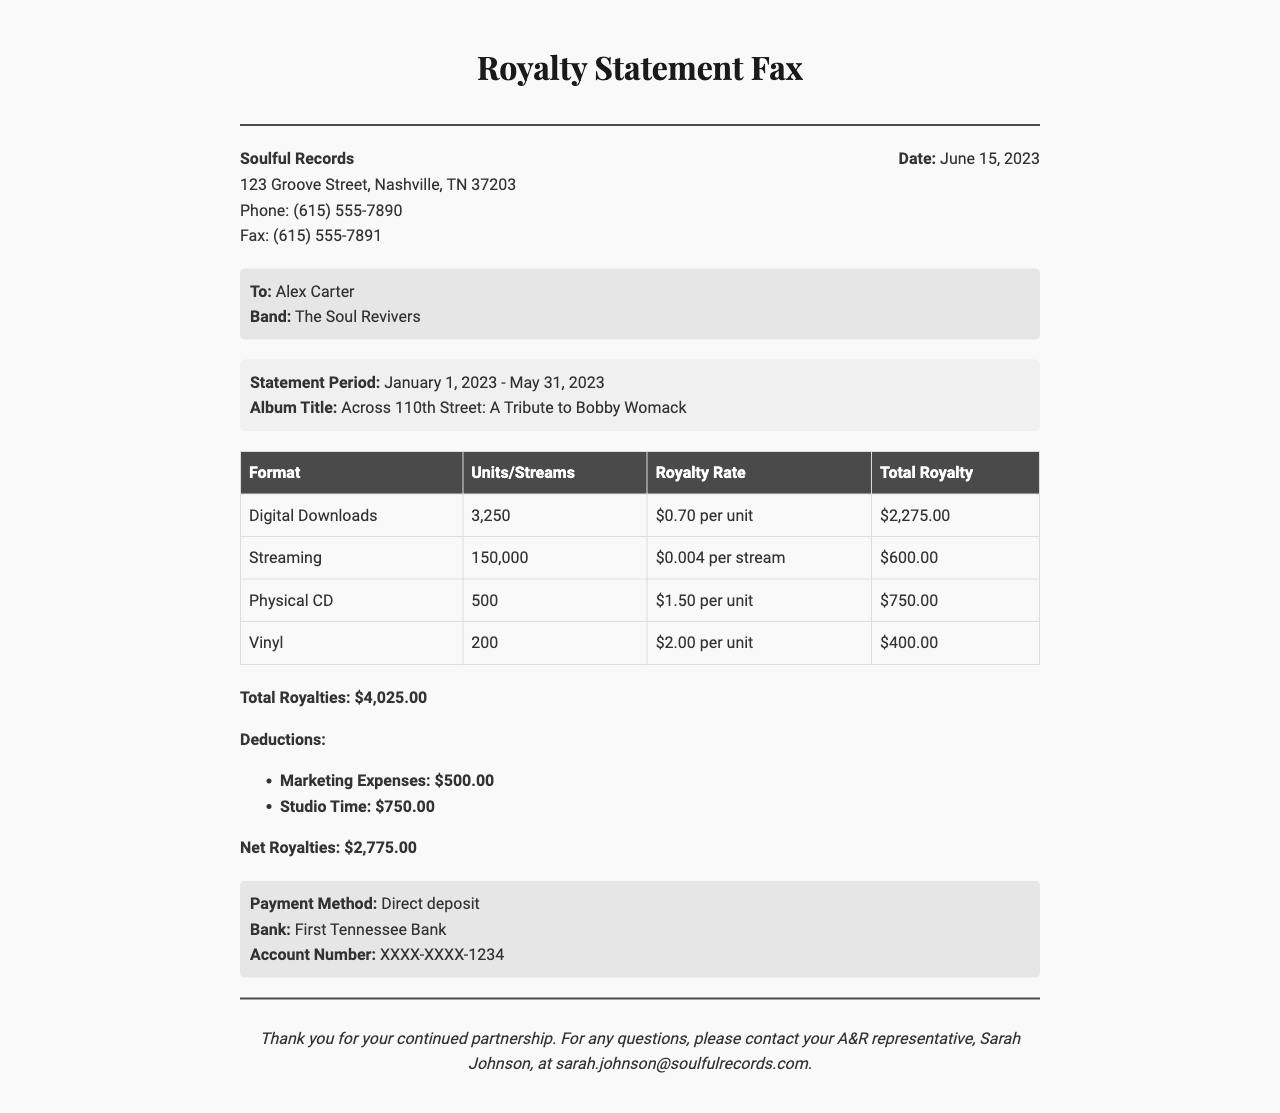What is the statement date? The statement date is mentioned in the document under the label info section.
Answer: June 15, 2023 What is the album title? The album title is provided in the statement details section.
Answer: Across 110th Street: A Tribute to Bobby Womack How many units were sold in digital downloads? The number of units sold is listed in the table under the Digital Downloads row.
Answer: 3,250 What is the total royalty amount? The total royalty amount is summarized in the totals section at the end of the document.
Answer: $4,025.00 What is the net royalties amount after deductions? The net royalties after deductions is provided in the totals section.
Answer: $2,775.00 What are the marketing expenses? The marketing expenses are listed under the deductions in the totals section.
Answer: $500.00 What payment method is used? The payment method is specified in the payment details section of the document.
Answer: Direct deposit Who is the A&R representative? The A&R representative's name is stated in the footer of the document.
Answer: Sarah Johnson How many units of vinyl were sold? The number of vinyl units sold is found in the table under the Vinyl row.
Answer: 200 